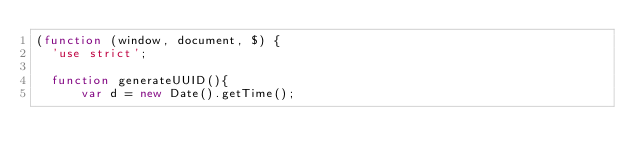Convert code to text. <code><loc_0><loc_0><loc_500><loc_500><_JavaScript_>(function (window, document, $) {
  'use strict';

  function generateUUID(){
      var d = new Date().getTime();</code> 